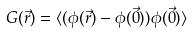Convert formula to latex. <formula><loc_0><loc_0><loc_500><loc_500>G ( \vec { r } ) = \langle ( \phi ( \vec { r } ) - \phi ( \vec { 0 } ) ) \phi ( \vec { 0 } ) \rangle</formula> 